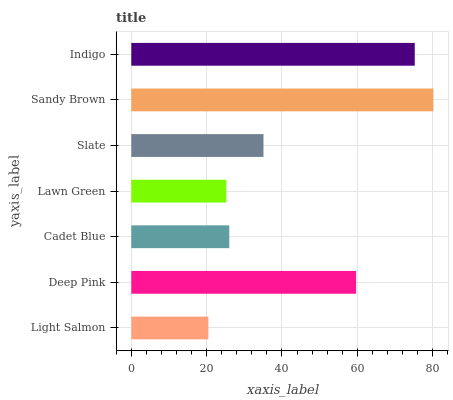Is Light Salmon the minimum?
Answer yes or no. Yes. Is Sandy Brown the maximum?
Answer yes or no. Yes. Is Deep Pink the minimum?
Answer yes or no. No. Is Deep Pink the maximum?
Answer yes or no. No. Is Deep Pink greater than Light Salmon?
Answer yes or no. Yes. Is Light Salmon less than Deep Pink?
Answer yes or no. Yes. Is Light Salmon greater than Deep Pink?
Answer yes or no. No. Is Deep Pink less than Light Salmon?
Answer yes or no. No. Is Slate the high median?
Answer yes or no. Yes. Is Slate the low median?
Answer yes or no. Yes. Is Deep Pink the high median?
Answer yes or no. No. Is Lawn Green the low median?
Answer yes or no. No. 